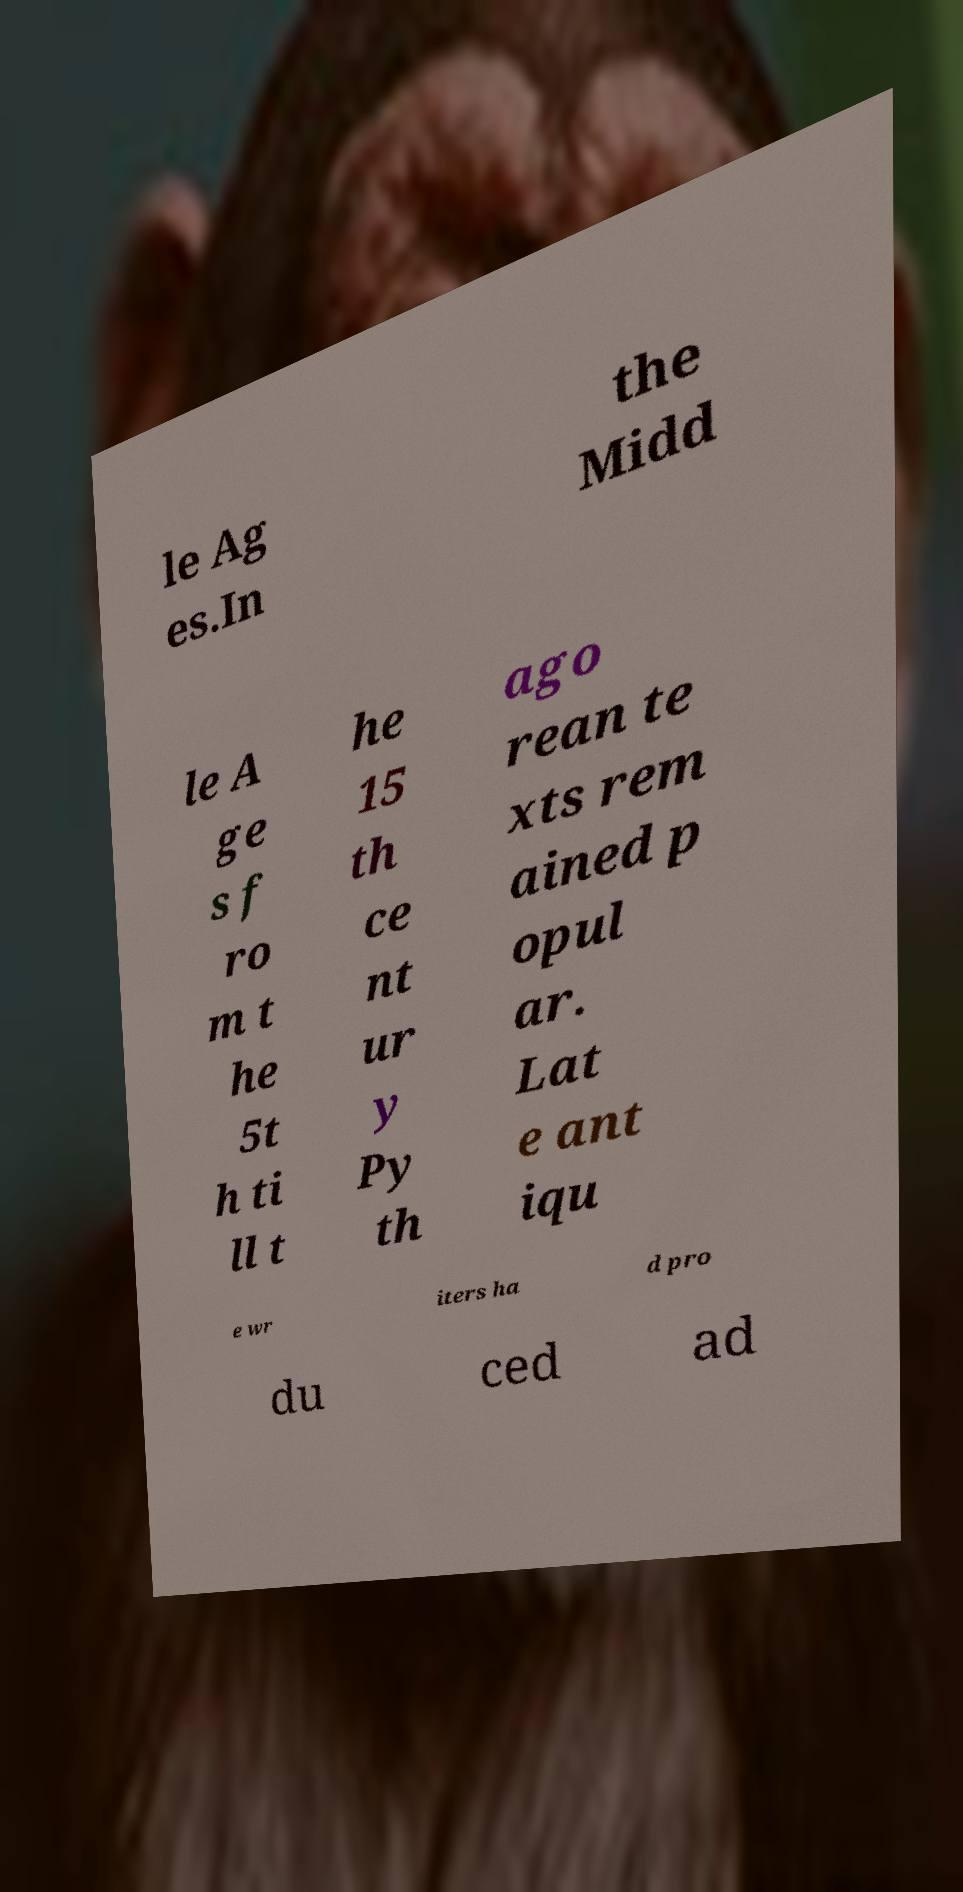Could you assist in decoding the text presented in this image and type it out clearly? le Ag es.In the Midd le A ge s f ro m t he 5t h ti ll t he 15 th ce nt ur y Py th ago rean te xts rem ained p opul ar. Lat e ant iqu e wr iters ha d pro du ced ad 